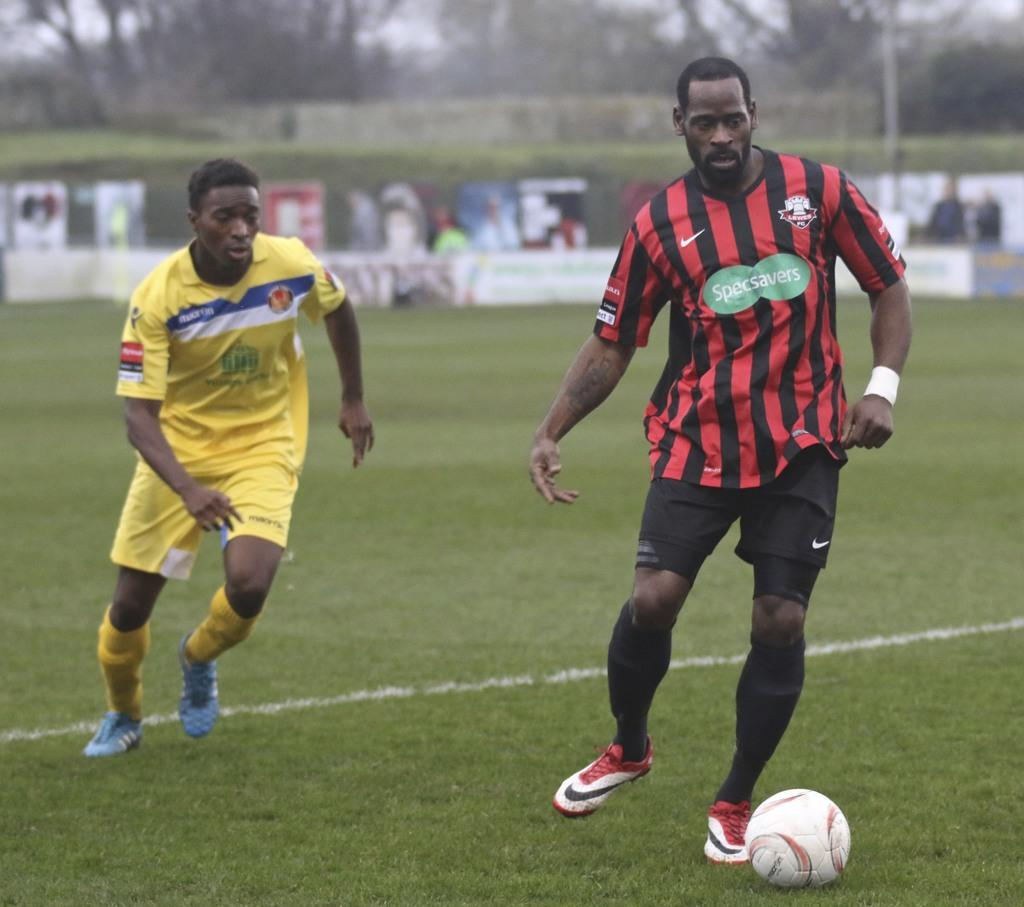<image>
Offer a succinct explanation of the picture presented. A player from the yellow team chases down a Specsavers player. 